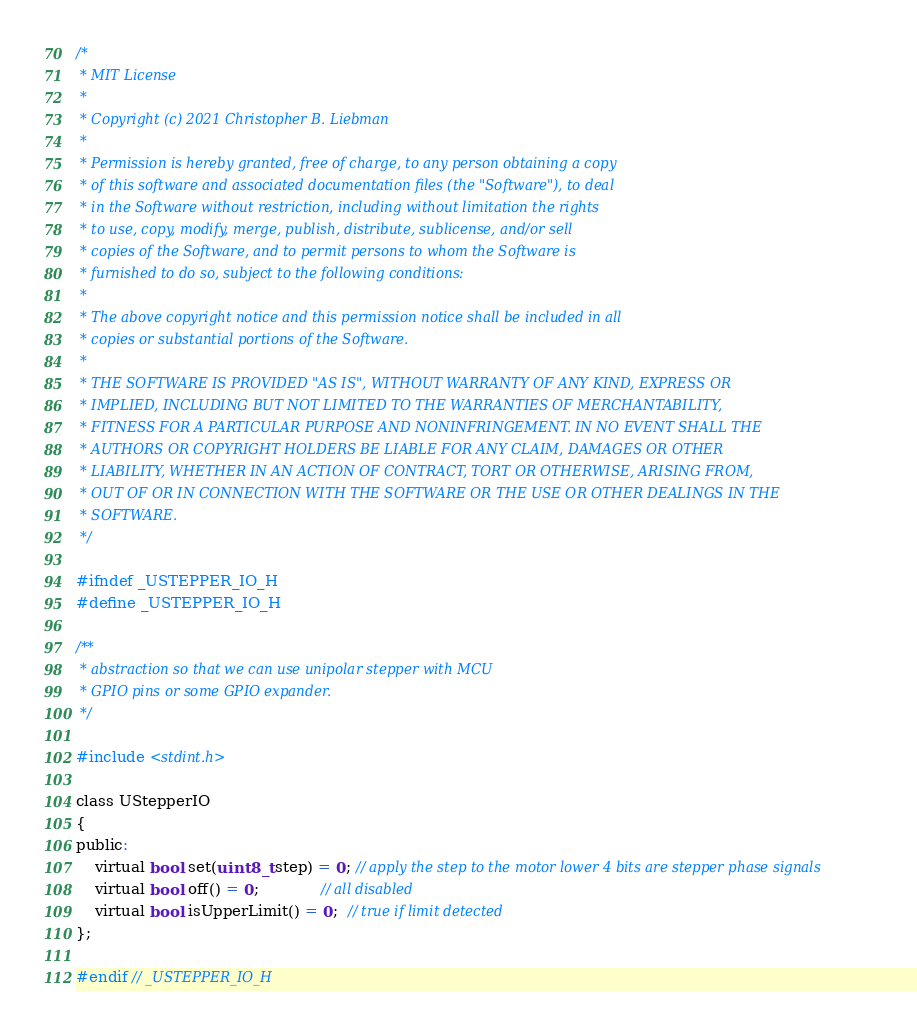<code> <loc_0><loc_0><loc_500><loc_500><_C_>/* 
 * MIT License
 *
 * Copyright (c) 2021 Christopher B. Liebman
 *
 * Permission is hereby granted, free of charge, to any person obtaining a copy
 * of this software and associated documentation files (the "Software"), to deal
 * in the Software without restriction, including without limitation the rights
 * to use, copy, modify, merge, publish, distribute, sublicense, and/or sell
 * copies of the Software, and to permit persons to whom the Software is
 * furnished to do so, subject to the following conditions:
 *
 * The above copyright notice and this permission notice shall be included in all
 * copies or substantial portions of the Software.
 *
 * THE SOFTWARE IS PROVIDED "AS IS", WITHOUT WARRANTY OF ANY KIND, EXPRESS OR
 * IMPLIED, INCLUDING BUT NOT LIMITED TO THE WARRANTIES OF MERCHANTABILITY,
 * FITNESS FOR A PARTICULAR PURPOSE AND NONINFRINGEMENT. IN NO EVENT SHALL THE
 * AUTHORS OR COPYRIGHT HOLDERS BE LIABLE FOR ANY CLAIM, DAMAGES OR OTHER
 * LIABILITY, WHETHER IN AN ACTION OF CONTRACT, TORT OR OTHERWISE, ARISING FROM,
 * OUT OF OR IN CONNECTION WITH THE SOFTWARE OR THE USE OR OTHER DEALINGS IN THE
 * SOFTWARE.
 */

#ifndef _USTEPPER_IO_H
#define _USTEPPER_IO_H

/**
 * abstraction so that we can use unipolar stepper with MCU
 * GPIO pins or some GPIO expander.
 */

#include <stdint.h>

class UStepperIO
{
public:
    virtual bool set(uint8_t step) = 0; // apply the step to the motor lower 4 bits are stepper phase signals
    virtual bool off() = 0;             // all disabled
    virtual bool isUpperLimit() = 0;  // true if limit detected
};

#endif // _USTEPPER_IO_H
</code> 